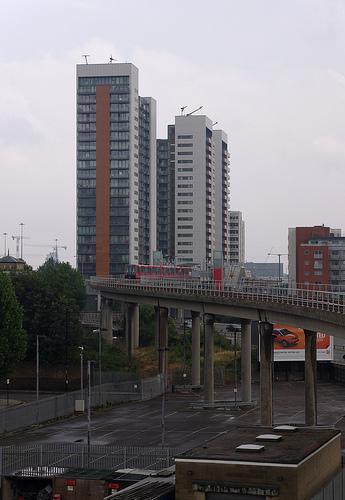How many skyscrapers are in the image?
Give a very brief answer. 4. 